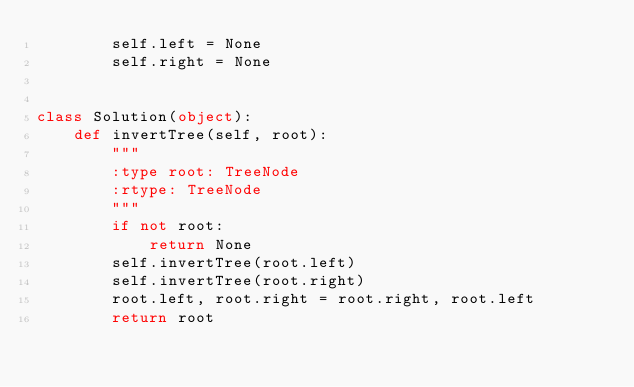Convert code to text. <code><loc_0><loc_0><loc_500><loc_500><_Python_>        self.left = None
        self.right = None


class Solution(object):
    def invertTree(self, root):
        """
        :type root: TreeNode
        :rtype: TreeNode
        """
        if not root:
            return None
        self.invertTree(root.left)
        self.invertTree(root.right)
        root.left, root.right = root.right, root.left
        return root
</code> 